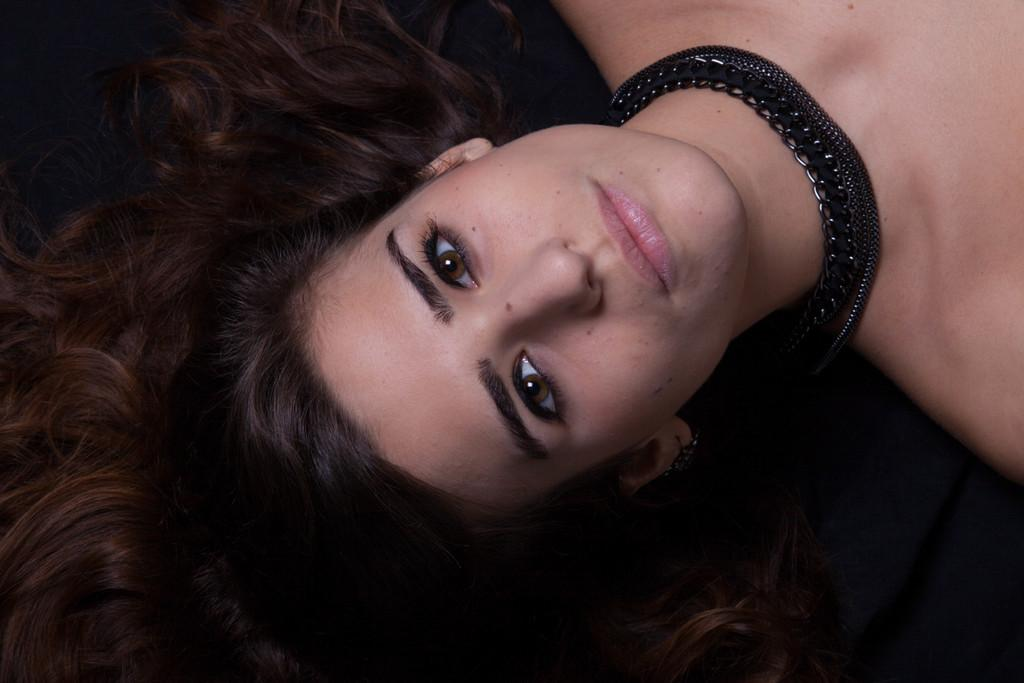What is the main subject of the picture? The main subject of the picture is a woman. What is the woman wearing in the picture? The woman is wearing a black color necklace. What type of hat is the woman wearing in the picture? There is no hat visible in the picture; the woman is only wearing a black color necklace. 